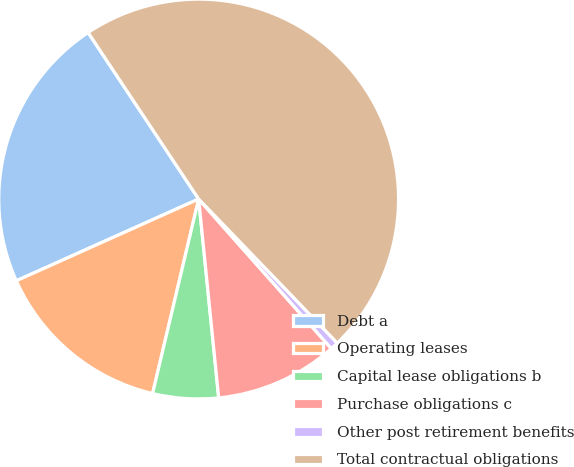Convert chart. <chart><loc_0><loc_0><loc_500><loc_500><pie_chart><fcel>Debt a<fcel>Operating leases<fcel>Capital lease obligations b<fcel>Purchase obligations c<fcel>Other post retirement benefits<fcel>Total contractual obligations<nl><fcel>22.38%<fcel>14.59%<fcel>5.3%<fcel>9.95%<fcel>0.65%<fcel>47.13%<nl></chart> 